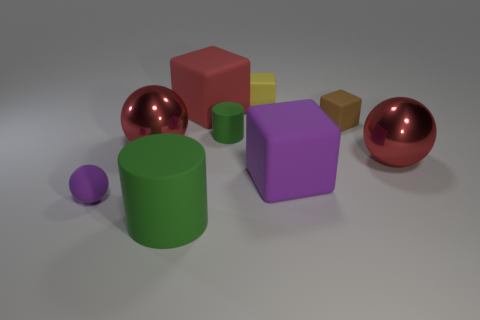Add 1 tiny purple matte things. How many objects exist? 10 Subtract all cylinders. How many objects are left? 7 Subtract all matte balls. Subtract all large metal spheres. How many objects are left? 6 Add 7 large green cylinders. How many large green cylinders are left? 8 Add 7 large purple matte blocks. How many large purple matte blocks exist? 8 Subtract 0 gray cylinders. How many objects are left? 9 